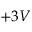Convert formula to latex. <formula><loc_0><loc_0><loc_500><loc_500>+ 3 V</formula> 